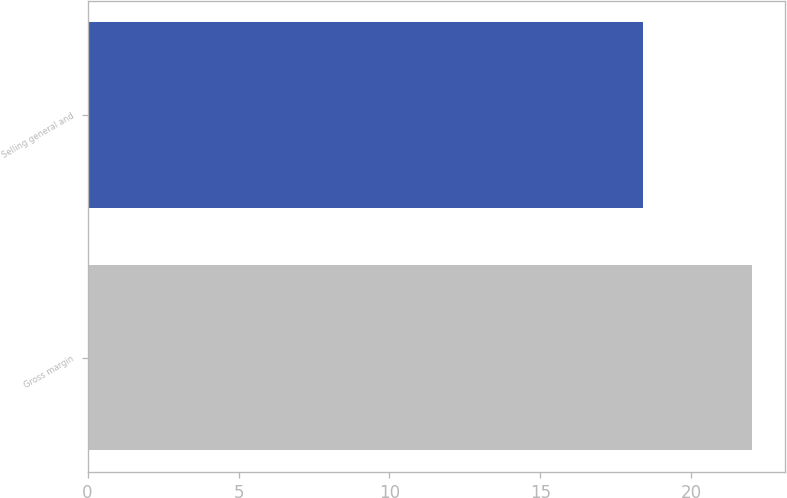Convert chart to OTSL. <chart><loc_0><loc_0><loc_500><loc_500><bar_chart><fcel>Gross margin<fcel>Selling general and<nl><fcel>22<fcel>18.4<nl></chart> 